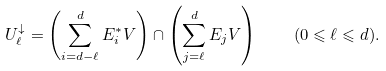Convert formula to latex. <formula><loc_0><loc_0><loc_500><loc_500>U _ { \ell } ^ { \downarrow } = \left ( \sum _ { i = d - \ell } ^ { d } E _ { i } ^ { * } V \right ) \cap \left ( \sum _ { j = \ell } ^ { d } E _ { j } V \right ) \quad ( 0 \leqslant \ell \leqslant d ) .</formula> 